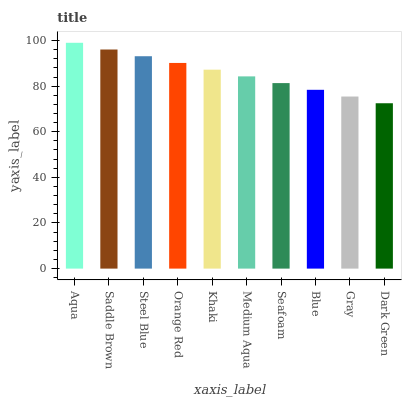Is Saddle Brown the minimum?
Answer yes or no. No. Is Saddle Brown the maximum?
Answer yes or no. No. Is Aqua greater than Saddle Brown?
Answer yes or no. Yes. Is Saddle Brown less than Aqua?
Answer yes or no. Yes. Is Saddle Brown greater than Aqua?
Answer yes or no. No. Is Aqua less than Saddle Brown?
Answer yes or no. No. Is Khaki the high median?
Answer yes or no. Yes. Is Medium Aqua the low median?
Answer yes or no. Yes. Is Seafoam the high median?
Answer yes or no. No. Is Dark Green the low median?
Answer yes or no. No. 